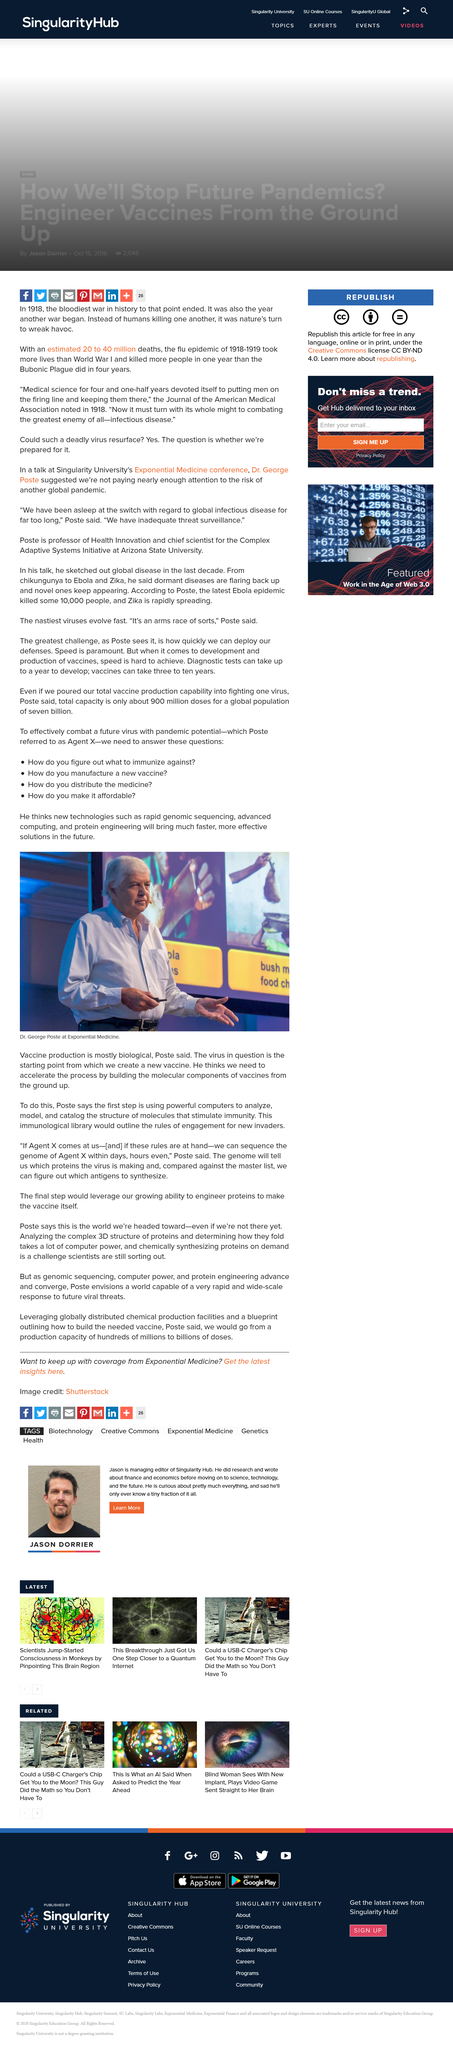List a handful of essential elements in this visual. Dr. Poste asserts that vaccine production is largely driven by biological processes. The man in the photograph is Dr. George Poste. The man in the photograph is speaking at an event called Exponential Medicine. 